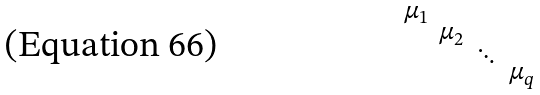<formula> <loc_0><loc_0><loc_500><loc_500>\begin{smallmatrix} \mu _ { 1 } & & & \\ & \mu _ { 2 } & & \\ & & \ddots & \\ & & & \mu _ { q } \end{smallmatrix}</formula> 